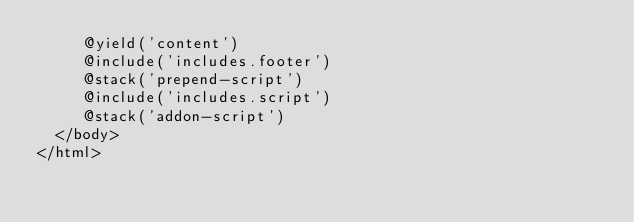<code> <loc_0><loc_0><loc_500><loc_500><_PHP_>     @yield('content')
     @include('includes.footer')
     @stack('prepend-script')
     @include('includes.script')
     @stack('addon-script')
  </body>
</html>
</code> 